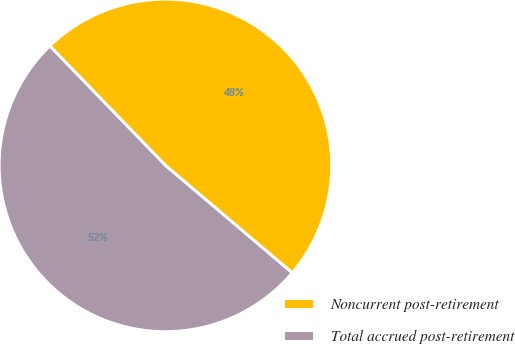Convert chart to OTSL. <chart><loc_0><loc_0><loc_500><loc_500><pie_chart><fcel>Noncurrent post-retirement<fcel>Total accrued post-retirement<nl><fcel>48.43%<fcel>51.57%<nl></chart> 